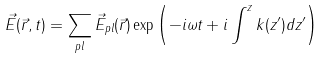<formula> <loc_0><loc_0><loc_500><loc_500>\vec { E } ( \vec { r } , t ) = \sum _ { p l } \vec { E } _ { p l } ( \vec { r } ) \exp \left ( - i \omega t + i \int ^ { z } k ( z ^ { \prime } ) d z ^ { \prime } \right )</formula> 